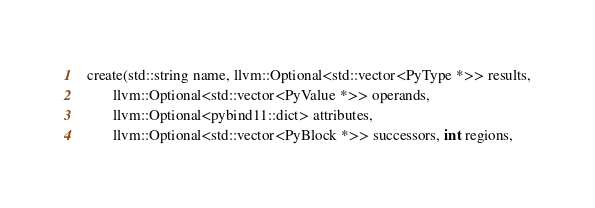Convert code to text. <code><loc_0><loc_0><loc_500><loc_500><_C_>  create(std::string name, llvm::Optional<std::vector<PyType *>> results,
         llvm::Optional<std::vector<PyValue *>> operands,
         llvm::Optional<pybind11::dict> attributes,
         llvm::Optional<std::vector<PyBlock *>> successors, int regions,</code> 